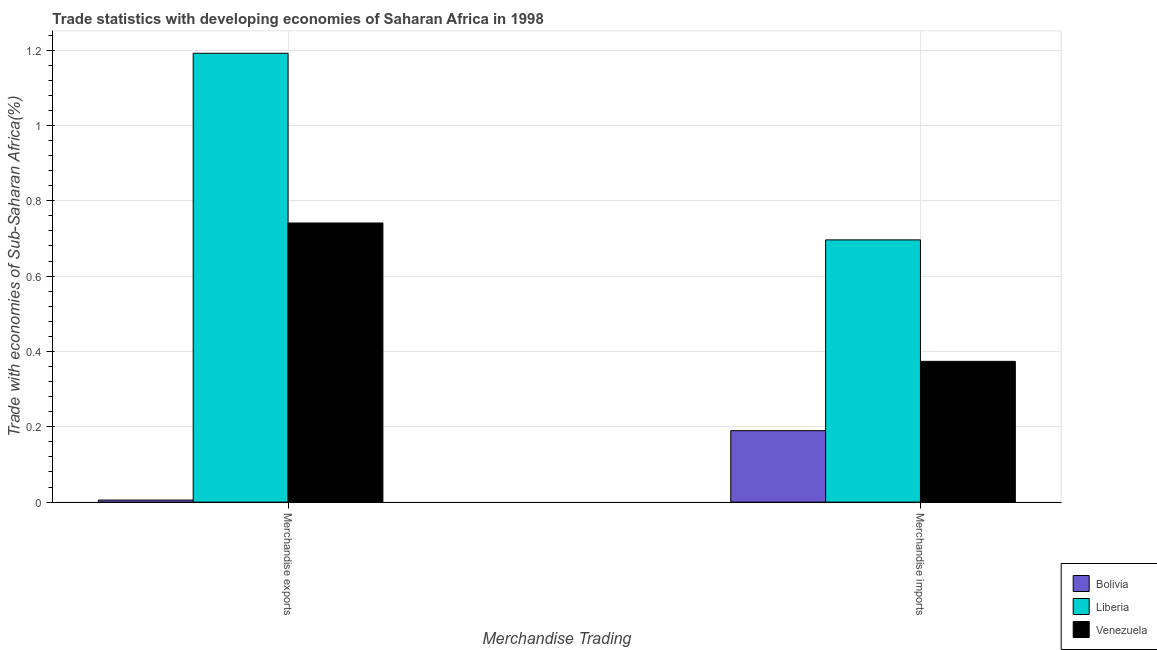What is the label of the 1st group of bars from the left?
Provide a short and direct response. Merchandise exports. What is the merchandise exports in Liberia?
Offer a very short reply. 1.19. Across all countries, what is the maximum merchandise imports?
Your response must be concise. 0.7. Across all countries, what is the minimum merchandise exports?
Ensure brevity in your answer.  0.01. In which country was the merchandise imports maximum?
Give a very brief answer. Liberia. What is the total merchandise imports in the graph?
Your answer should be very brief. 1.26. What is the difference between the merchandise imports in Venezuela and that in Liberia?
Ensure brevity in your answer.  -0.32. What is the difference between the merchandise exports in Venezuela and the merchandise imports in Liberia?
Your answer should be very brief. 0.04. What is the average merchandise exports per country?
Your response must be concise. 0.65. What is the difference between the merchandise imports and merchandise exports in Liberia?
Your response must be concise. -0.5. What is the ratio of the merchandise imports in Bolivia to that in Venezuela?
Make the answer very short. 0.51. Is the merchandise exports in Venezuela less than that in Liberia?
Offer a terse response. Yes. What does the 3rd bar from the left in Merchandise imports represents?
Make the answer very short. Venezuela. What does the 1st bar from the right in Merchandise imports represents?
Provide a succinct answer. Venezuela. How many countries are there in the graph?
Offer a very short reply. 3. What is the difference between two consecutive major ticks on the Y-axis?
Provide a short and direct response. 0.2. Are the values on the major ticks of Y-axis written in scientific E-notation?
Your answer should be compact. No. Does the graph contain any zero values?
Offer a terse response. No. Does the graph contain grids?
Your answer should be very brief. Yes. How many legend labels are there?
Your answer should be compact. 3. What is the title of the graph?
Ensure brevity in your answer.  Trade statistics with developing economies of Saharan Africa in 1998. Does "Syrian Arab Republic" appear as one of the legend labels in the graph?
Your answer should be very brief. No. What is the label or title of the X-axis?
Provide a succinct answer. Merchandise Trading. What is the label or title of the Y-axis?
Give a very brief answer. Trade with economies of Sub-Saharan Africa(%). What is the Trade with economies of Sub-Saharan Africa(%) in Bolivia in Merchandise exports?
Keep it short and to the point. 0.01. What is the Trade with economies of Sub-Saharan Africa(%) of Liberia in Merchandise exports?
Provide a succinct answer. 1.19. What is the Trade with economies of Sub-Saharan Africa(%) of Venezuela in Merchandise exports?
Provide a short and direct response. 0.74. What is the Trade with economies of Sub-Saharan Africa(%) of Bolivia in Merchandise imports?
Provide a short and direct response. 0.19. What is the Trade with economies of Sub-Saharan Africa(%) in Liberia in Merchandise imports?
Offer a very short reply. 0.7. What is the Trade with economies of Sub-Saharan Africa(%) in Venezuela in Merchandise imports?
Ensure brevity in your answer.  0.37. Across all Merchandise Trading, what is the maximum Trade with economies of Sub-Saharan Africa(%) in Bolivia?
Your answer should be very brief. 0.19. Across all Merchandise Trading, what is the maximum Trade with economies of Sub-Saharan Africa(%) of Liberia?
Your answer should be compact. 1.19. Across all Merchandise Trading, what is the maximum Trade with economies of Sub-Saharan Africa(%) in Venezuela?
Give a very brief answer. 0.74. Across all Merchandise Trading, what is the minimum Trade with economies of Sub-Saharan Africa(%) of Bolivia?
Give a very brief answer. 0.01. Across all Merchandise Trading, what is the minimum Trade with economies of Sub-Saharan Africa(%) in Liberia?
Offer a terse response. 0.7. Across all Merchandise Trading, what is the minimum Trade with economies of Sub-Saharan Africa(%) in Venezuela?
Ensure brevity in your answer.  0.37. What is the total Trade with economies of Sub-Saharan Africa(%) in Bolivia in the graph?
Your answer should be compact. 0.2. What is the total Trade with economies of Sub-Saharan Africa(%) in Liberia in the graph?
Your response must be concise. 1.89. What is the total Trade with economies of Sub-Saharan Africa(%) in Venezuela in the graph?
Your answer should be very brief. 1.11. What is the difference between the Trade with economies of Sub-Saharan Africa(%) of Bolivia in Merchandise exports and that in Merchandise imports?
Ensure brevity in your answer.  -0.18. What is the difference between the Trade with economies of Sub-Saharan Africa(%) of Liberia in Merchandise exports and that in Merchandise imports?
Offer a terse response. 0.5. What is the difference between the Trade with economies of Sub-Saharan Africa(%) in Venezuela in Merchandise exports and that in Merchandise imports?
Keep it short and to the point. 0.37. What is the difference between the Trade with economies of Sub-Saharan Africa(%) of Bolivia in Merchandise exports and the Trade with economies of Sub-Saharan Africa(%) of Liberia in Merchandise imports?
Keep it short and to the point. -0.69. What is the difference between the Trade with economies of Sub-Saharan Africa(%) of Bolivia in Merchandise exports and the Trade with economies of Sub-Saharan Africa(%) of Venezuela in Merchandise imports?
Make the answer very short. -0.37. What is the difference between the Trade with economies of Sub-Saharan Africa(%) in Liberia in Merchandise exports and the Trade with economies of Sub-Saharan Africa(%) in Venezuela in Merchandise imports?
Make the answer very short. 0.82. What is the average Trade with economies of Sub-Saharan Africa(%) in Bolivia per Merchandise Trading?
Your answer should be very brief. 0.1. What is the average Trade with economies of Sub-Saharan Africa(%) in Liberia per Merchandise Trading?
Offer a very short reply. 0.94. What is the average Trade with economies of Sub-Saharan Africa(%) of Venezuela per Merchandise Trading?
Provide a succinct answer. 0.56. What is the difference between the Trade with economies of Sub-Saharan Africa(%) of Bolivia and Trade with economies of Sub-Saharan Africa(%) of Liberia in Merchandise exports?
Your answer should be very brief. -1.19. What is the difference between the Trade with economies of Sub-Saharan Africa(%) of Bolivia and Trade with economies of Sub-Saharan Africa(%) of Venezuela in Merchandise exports?
Give a very brief answer. -0.74. What is the difference between the Trade with economies of Sub-Saharan Africa(%) of Liberia and Trade with economies of Sub-Saharan Africa(%) of Venezuela in Merchandise exports?
Ensure brevity in your answer.  0.45. What is the difference between the Trade with economies of Sub-Saharan Africa(%) of Bolivia and Trade with economies of Sub-Saharan Africa(%) of Liberia in Merchandise imports?
Your response must be concise. -0.51. What is the difference between the Trade with economies of Sub-Saharan Africa(%) of Bolivia and Trade with economies of Sub-Saharan Africa(%) of Venezuela in Merchandise imports?
Your answer should be very brief. -0.18. What is the difference between the Trade with economies of Sub-Saharan Africa(%) in Liberia and Trade with economies of Sub-Saharan Africa(%) in Venezuela in Merchandise imports?
Your answer should be compact. 0.32. What is the ratio of the Trade with economies of Sub-Saharan Africa(%) in Bolivia in Merchandise exports to that in Merchandise imports?
Provide a succinct answer. 0.03. What is the ratio of the Trade with economies of Sub-Saharan Africa(%) in Liberia in Merchandise exports to that in Merchandise imports?
Your response must be concise. 1.71. What is the ratio of the Trade with economies of Sub-Saharan Africa(%) of Venezuela in Merchandise exports to that in Merchandise imports?
Offer a very short reply. 1.98. What is the difference between the highest and the second highest Trade with economies of Sub-Saharan Africa(%) in Bolivia?
Provide a short and direct response. 0.18. What is the difference between the highest and the second highest Trade with economies of Sub-Saharan Africa(%) of Liberia?
Ensure brevity in your answer.  0.5. What is the difference between the highest and the second highest Trade with economies of Sub-Saharan Africa(%) in Venezuela?
Provide a short and direct response. 0.37. What is the difference between the highest and the lowest Trade with economies of Sub-Saharan Africa(%) of Bolivia?
Offer a very short reply. 0.18. What is the difference between the highest and the lowest Trade with economies of Sub-Saharan Africa(%) of Liberia?
Ensure brevity in your answer.  0.5. What is the difference between the highest and the lowest Trade with economies of Sub-Saharan Africa(%) in Venezuela?
Provide a short and direct response. 0.37. 